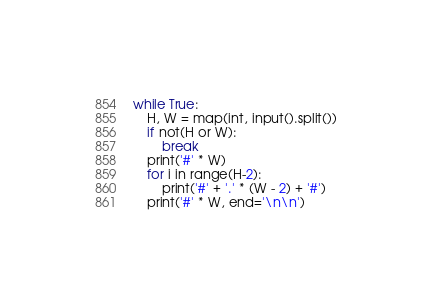<code> <loc_0><loc_0><loc_500><loc_500><_Python_>while True:
    H, W = map(int, input().split())
    if not(H or W):
        break
    print('#' * W)
    for i in range(H-2):
        print('#' + '.' * (W - 2) + '#')
    print('#' * W, end='\n\n')</code> 